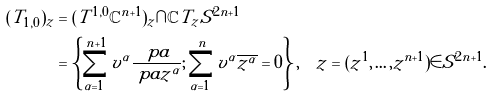Convert formula to latex. <formula><loc_0><loc_0><loc_500><loc_500>( T _ { 1 , 0 } ) _ { z } & = ( T ^ { 1 , 0 } \mathbb { C } ^ { n + 1 } ) _ { z } \cap \mathbb { C } T _ { z } S ^ { 2 n + 1 } \\ & = \left \{ \sum _ { \alpha = 1 } ^ { n + 1 } v ^ { \alpha } \frac { \ p a } { \ p a z ^ { \alpha } } ; \sum _ { \alpha = 1 } ^ { n } v ^ { \alpha } \overline { z ^ { \alpha } } = 0 \right \} , \quad z = ( z ^ { 1 } , \dots , z ^ { n + 1 } ) \in S ^ { 2 n + 1 } .</formula> 